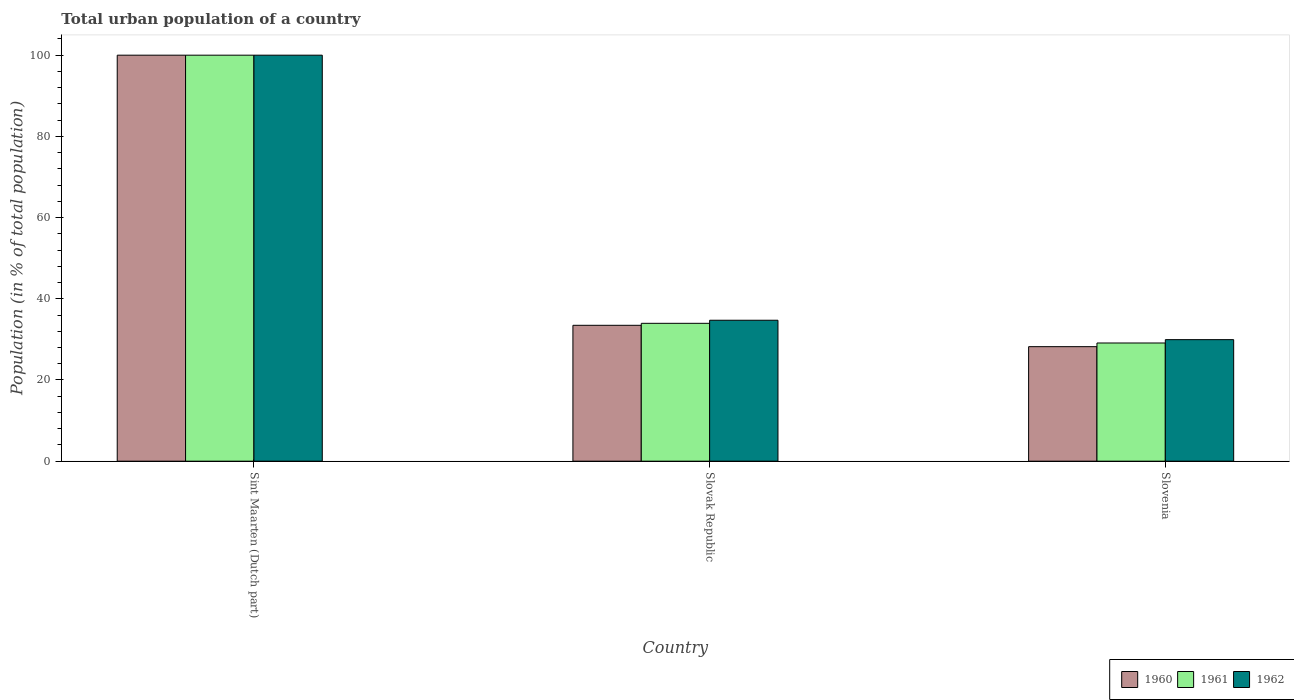How many different coloured bars are there?
Provide a succinct answer. 3. Are the number of bars per tick equal to the number of legend labels?
Offer a terse response. Yes. Are the number of bars on each tick of the X-axis equal?
Provide a short and direct response. Yes. How many bars are there on the 2nd tick from the left?
Your answer should be compact. 3. How many bars are there on the 3rd tick from the right?
Give a very brief answer. 3. What is the label of the 2nd group of bars from the left?
Your response must be concise. Slovak Republic. In how many cases, is the number of bars for a given country not equal to the number of legend labels?
Give a very brief answer. 0. What is the urban population in 1962 in Slovak Republic?
Your answer should be very brief. 34.71. Across all countries, what is the minimum urban population in 1960?
Provide a short and direct response. 28.2. In which country was the urban population in 1961 maximum?
Your response must be concise. Sint Maarten (Dutch part). In which country was the urban population in 1962 minimum?
Keep it short and to the point. Slovenia. What is the total urban population in 1960 in the graph?
Provide a succinct answer. 161.67. What is the difference between the urban population in 1960 in Sint Maarten (Dutch part) and that in Slovenia?
Provide a short and direct response. 71.8. What is the difference between the urban population in 1962 in Slovenia and the urban population in 1960 in Sint Maarten (Dutch part)?
Offer a very short reply. -70.07. What is the average urban population in 1961 per country?
Give a very brief answer. 54.35. What is the difference between the urban population of/in 1960 and urban population of/in 1961 in Sint Maarten (Dutch part)?
Offer a very short reply. 0. What is the ratio of the urban population in 1961 in Sint Maarten (Dutch part) to that in Slovenia?
Provide a succinct answer. 3.44. Is the difference between the urban population in 1960 in Slovak Republic and Slovenia greater than the difference between the urban population in 1961 in Slovak Republic and Slovenia?
Your answer should be compact. Yes. What is the difference between the highest and the second highest urban population in 1960?
Give a very brief answer. -66.54. What is the difference between the highest and the lowest urban population in 1960?
Provide a short and direct response. 71.8. In how many countries, is the urban population in 1962 greater than the average urban population in 1962 taken over all countries?
Provide a succinct answer. 1. What does the 1st bar from the left in Slovak Republic represents?
Your answer should be compact. 1960. What does the 2nd bar from the right in Slovenia represents?
Provide a short and direct response. 1961. Are all the bars in the graph horizontal?
Ensure brevity in your answer.  No. How many countries are there in the graph?
Keep it short and to the point. 3. Are the values on the major ticks of Y-axis written in scientific E-notation?
Your answer should be compact. No. Where does the legend appear in the graph?
Offer a terse response. Bottom right. What is the title of the graph?
Keep it short and to the point. Total urban population of a country. What is the label or title of the Y-axis?
Your response must be concise. Population (in % of total population). What is the Population (in % of total population) in 1960 in Slovak Republic?
Your response must be concise. 33.46. What is the Population (in % of total population) of 1961 in Slovak Republic?
Your answer should be compact. 33.95. What is the Population (in % of total population) in 1962 in Slovak Republic?
Offer a terse response. 34.71. What is the Population (in % of total population) in 1960 in Slovenia?
Keep it short and to the point. 28.2. What is the Population (in % of total population) in 1961 in Slovenia?
Your response must be concise. 29.11. What is the Population (in % of total population) of 1962 in Slovenia?
Your answer should be very brief. 29.93. Across all countries, what is the maximum Population (in % of total population) in 1960?
Provide a succinct answer. 100. Across all countries, what is the maximum Population (in % of total population) in 1961?
Make the answer very short. 100. Across all countries, what is the minimum Population (in % of total population) of 1960?
Provide a short and direct response. 28.2. Across all countries, what is the minimum Population (in % of total population) of 1961?
Give a very brief answer. 29.11. Across all countries, what is the minimum Population (in % of total population) of 1962?
Offer a very short reply. 29.93. What is the total Population (in % of total population) in 1960 in the graph?
Your answer should be very brief. 161.67. What is the total Population (in % of total population) in 1961 in the graph?
Your response must be concise. 163.06. What is the total Population (in % of total population) in 1962 in the graph?
Your response must be concise. 164.65. What is the difference between the Population (in % of total population) of 1960 in Sint Maarten (Dutch part) and that in Slovak Republic?
Your response must be concise. 66.54. What is the difference between the Population (in % of total population) in 1961 in Sint Maarten (Dutch part) and that in Slovak Republic?
Provide a succinct answer. 66.05. What is the difference between the Population (in % of total population) in 1962 in Sint Maarten (Dutch part) and that in Slovak Republic?
Your response must be concise. 65.29. What is the difference between the Population (in % of total population) in 1960 in Sint Maarten (Dutch part) and that in Slovenia?
Ensure brevity in your answer.  71.8. What is the difference between the Population (in % of total population) of 1961 in Sint Maarten (Dutch part) and that in Slovenia?
Provide a succinct answer. 70.89. What is the difference between the Population (in % of total population) in 1962 in Sint Maarten (Dutch part) and that in Slovenia?
Offer a terse response. 70.07. What is the difference between the Population (in % of total population) in 1960 in Slovak Republic and that in Slovenia?
Make the answer very short. 5.26. What is the difference between the Population (in % of total population) in 1961 in Slovak Republic and that in Slovenia?
Make the answer very short. 4.85. What is the difference between the Population (in % of total population) of 1962 in Slovak Republic and that in Slovenia?
Make the answer very short. 4.78. What is the difference between the Population (in % of total population) in 1960 in Sint Maarten (Dutch part) and the Population (in % of total population) in 1961 in Slovak Republic?
Provide a short and direct response. 66.05. What is the difference between the Population (in % of total population) in 1960 in Sint Maarten (Dutch part) and the Population (in % of total population) in 1962 in Slovak Republic?
Offer a terse response. 65.29. What is the difference between the Population (in % of total population) of 1961 in Sint Maarten (Dutch part) and the Population (in % of total population) of 1962 in Slovak Republic?
Make the answer very short. 65.29. What is the difference between the Population (in % of total population) of 1960 in Sint Maarten (Dutch part) and the Population (in % of total population) of 1961 in Slovenia?
Make the answer very short. 70.89. What is the difference between the Population (in % of total population) of 1960 in Sint Maarten (Dutch part) and the Population (in % of total population) of 1962 in Slovenia?
Your response must be concise. 70.07. What is the difference between the Population (in % of total population) in 1961 in Sint Maarten (Dutch part) and the Population (in % of total population) in 1962 in Slovenia?
Provide a short and direct response. 70.07. What is the difference between the Population (in % of total population) in 1960 in Slovak Republic and the Population (in % of total population) in 1961 in Slovenia?
Keep it short and to the point. 4.36. What is the difference between the Population (in % of total population) of 1960 in Slovak Republic and the Population (in % of total population) of 1962 in Slovenia?
Offer a very short reply. 3.53. What is the difference between the Population (in % of total population) of 1961 in Slovak Republic and the Population (in % of total population) of 1962 in Slovenia?
Your answer should be compact. 4.02. What is the average Population (in % of total population) of 1960 per country?
Offer a very short reply. 53.89. What is the average Population (in % of total population) in 1961 per country?
Offer a very short reply. 54.35. What is the average Population (in % of total population) of 1962 per country?
Provide a short and direct response. 54.88. What is the difference between the Population (in % of total population) in 1960 and Population (in % of total population) in 1962 in Sint Maarten (Dutch part)?
Your answer should be very brief. 0. What is the difference between the Population (in % of total population) of 1960 and Population (in % of total population) of 1961 in Slovak Republic?
Provide a short and direct response. -0.49. What is the difference between the Population (in % of total population) of 1960 and Population (in % of total population) of 1962 in Slovak Republic?
Make the answer very short. -1.25. What is the difference between the Population (in % of total population) of 1961 and Population (in % of total population) of 1962 in Slovak Republic?
Keep it short and to the point. -0.76. What is the difference between the Population (in % of total population) of 1960 and Population (in % of total population) of 1961 in Slovenia?
Give a very brief answer. -0.9. What is the difference between the Population (in % of total population) of 1960 and Population (in % of total population) of 1962 in Slovenia?
Ensure brevity in your answer.  -1.73. What is the difference between the Population (in % of total population) of 1961 and Population (in % of total population) of 1962 in Slovenia?
Keep it short and to the point. -0.83. What is the ratio of the Population (in % of total population) of 1960 in Sint Maarten (Dutch part) to that in Slovak Republic?
Your response must be concise. 2.99. What is the ratio of the Population (in % of total population) of 1961 in Sint Maarten (Dutch part) to that in Slovak Republic?
Give a very brief answer. 2.95. What is the ratio of the Population (in % of total population) in 1962 in Sint Maarten (Dutch part) to that in Slovak Republic?
Make the answer very short. 2.88. What is the ratio of the Population (in % of total population) in 1960 in Sint Maarten (Dutch part) to that in Slovenia?
Make the answer very short. 3.55. What is the ratio of the Population (in % of total population) in 1961 in Sint Maarten (Dutch part) to that in Slovenia?
Your answer should be very brief. 3.44. What is the ratio of the Population (in % of total population) of 1962 in Sint Maarten (Dutch part) to that in Slovenia?
Keep it short and to the point. 3.34. What is the ratio of the Population (in % of total population) of 1960 in Slovak Republic to that in Slovenia?
Your answer should be compact. 1.19. What is the ratio of the Population (in % of total population) of 1961 in Slovak Republic to that in Slovenia?
Offer a terse response. 1.17. What is the ratio of the Population (in % of total population) of 1962 in Slovak Republic to that in Slovenia?
Give a very brief answer. 1.16. What is the difference between the highest and the second highest Population (in % of total population) of 1960?
Provide a short and direct response. 66.54. What is the difference between the highest and the second highest Population (in % of total population) of 1961?
Offer a very short reply. 66.05. What is the difference between the highest and the second highest Population (in % of total population) of 1962?
Your answer should be very brief. 65.29. What is the difference between the highest and the lowest Population (in % of total population) of 1960?
Keep it short and to the point. 71.8. What is the difference between the highest and the lowest Population (in % of total population) in 1961?
Your response must be concise. 70.89. What is the difference between the highest and the lowest Population (in % of total population) of 1962?
Make the answer very short. 70.07. 